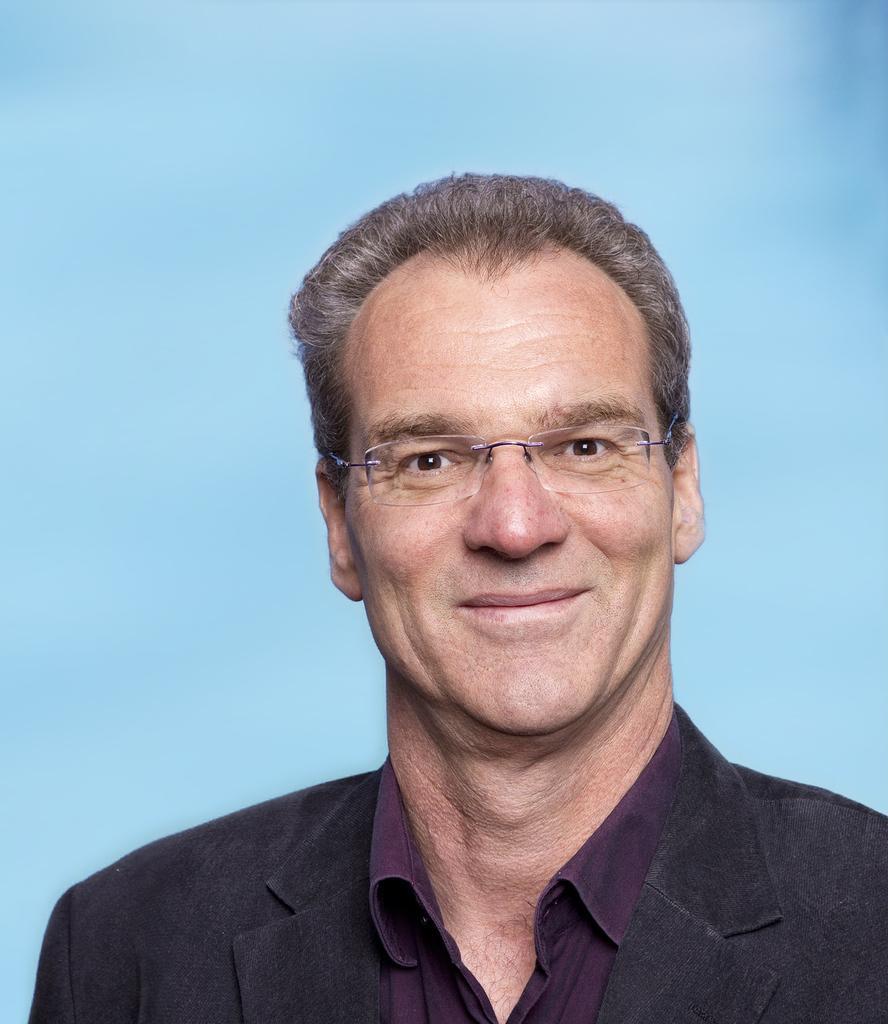Describe this image in one or two sentences. In this image I can see a man smiling. He is wearing spectacles and a suit. The background is blue. 